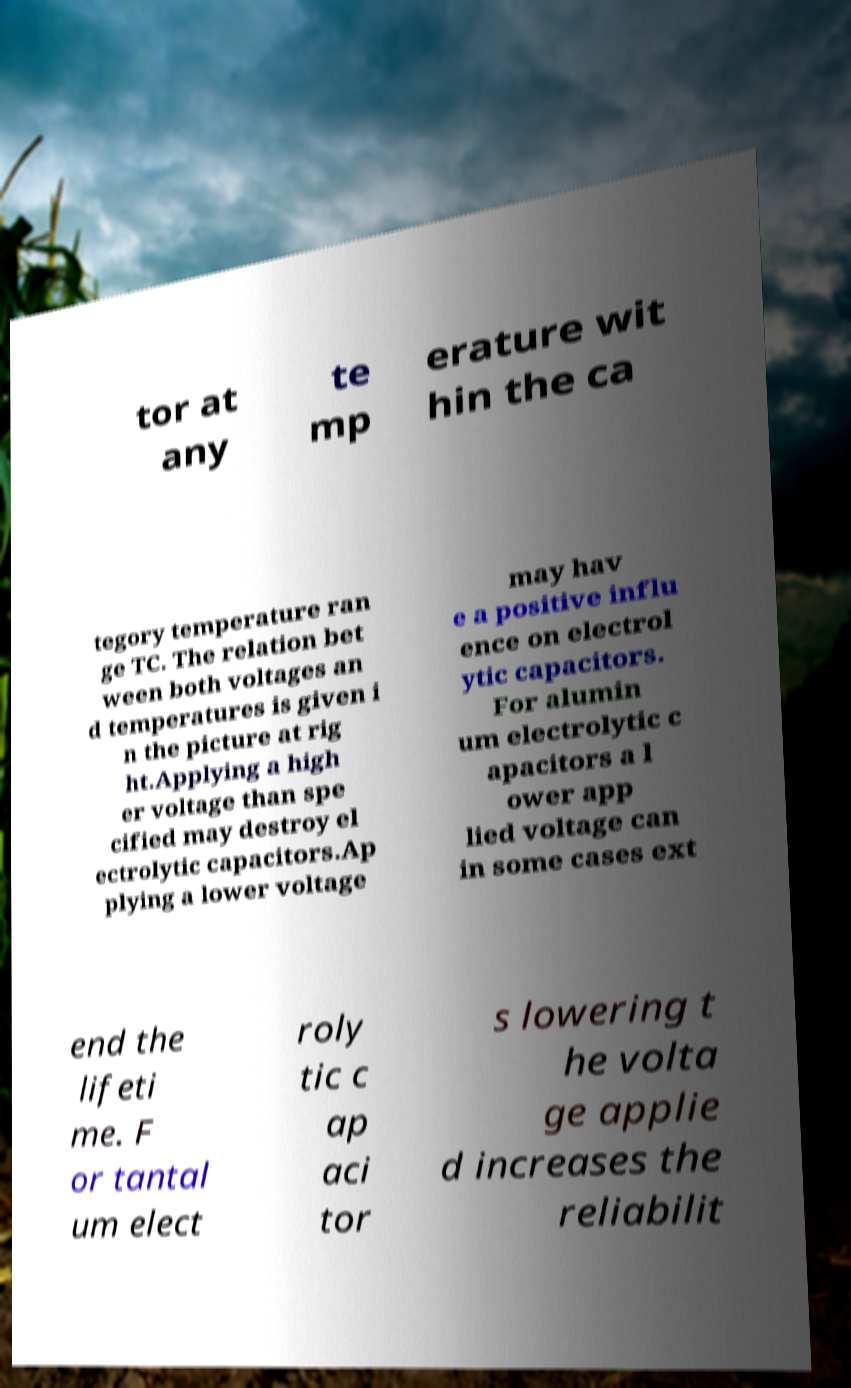Please identify and transcribe the text found in this image. tor at any te mp erature wit hin the ca tegory temperature ran ge TC. The relation bet ween both voltages an d temperatures is given i n the picture at rig ht.Applying a high er voltage than spe cified may destroy el ectrolytic capacitors.Ap plying a lower voltage may hav e a positive influ ence on electrol ytic capacitors. For alumin um electrolytic c apacitors a l ower app lied voltage can in some cases ext end the lifeti me. F or tantal um elect roly tic c ap aci tor s lowering t he volta ge applie d increases the reliabilit 